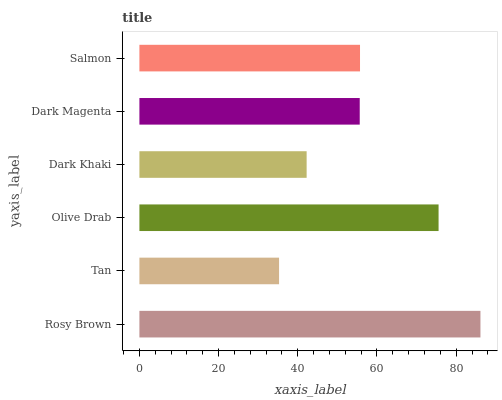Is Tan the minimum?
Answer yes or no. Yes. Is Rosy Brown the maximum?
Answer yes or no. Yes. Is Olive Drab the minimum?
Answer yes or no. No. Is Olive Drab the maximum?
Answer yes or no. No. Is Olive Drab greater than Tan?
Answer yes or no. Yes. Is Tan less than Olive Drab?
Answer yes or no. Yes. Is Tan greater than Olive Drab?
Answer yes or no. No. Is Olive Drab less than Tan?
Answer yes or no. No. Is Salmon the high median?
Answer yes or no. Yes. Is Dark Magenta the low median?
Answer yes or no. Yes. Is Rosy Brown the high median?
Answer yes or no. No. Is Salmon the low median?
Answer yes or no. No. 